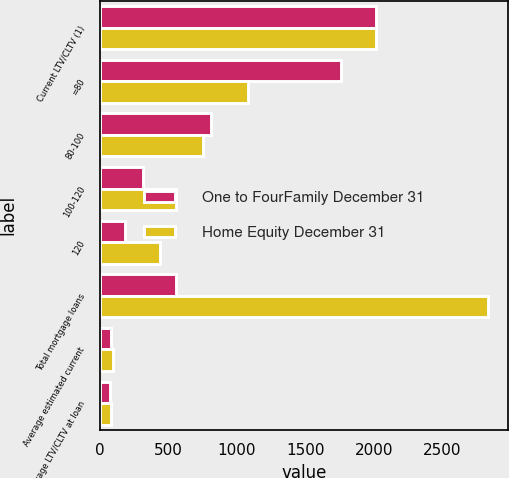Convert chart. <chart><loc_0><loc_0><loc_500><loc_500><stacked_bar_chart><ecel><fcel>Current LTV/CLTV (1)<fcel>=80<fcel>80-100<fcel>100-120<fcel>120<fcel>Total mortgage loans<fcel>Average estimated current<fcel>Average LTV/CLTV at loan<nl><fcel>One to FourFamily December 31<fcel>2014<fcel>1757<fcel>807<fcel>311<fcel>185<fcel>557<fcel>79<fcel>71<nl><fcel>Home Equity December 31<fcel>2014<fcel>1081<fcel>755<fcel>557<fcel>441<fcel>2834<fcel>92<fcel>80<nl></chart> 